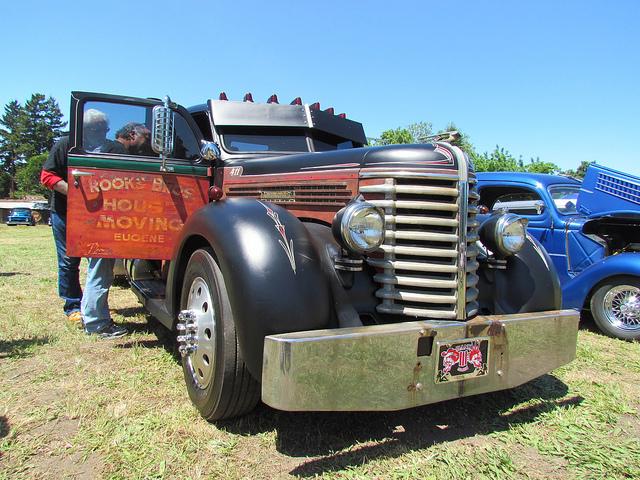Is it daytime?
Give a very brief answer. Yes. What kind of truck is in the picture?
Be succinct. Moving. What color is the truck?
Write a very short answer. Black and red. What business uses the truck?
Be succinct. House moving. 